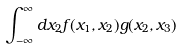<formula> <loc_0><loc_0><loc_500><loc_500>\int _ { - \infty } ^ { \infty } d x _ { 2 } f ( x _ { 1 } , x _ { 2 } ) g ( x _ { 2 } , x _ { 3 } )</formula> 